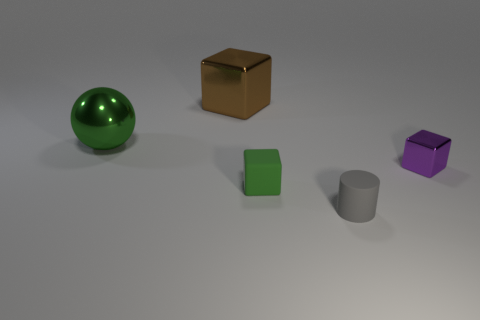What size is the object that is the same color as the rubber block?
Offer a very short reply. Large. How many other objects are the same shape as the big green thing?
Your answer should be very brief. 0. Does the shiny block that is behind the purple cube have the same color as the big sphere?
Provide a short and direct response. No. Are there any small cubes of the same color as the matte cylinder?
Make the answer very short. No. How many green metal things are to the right of the big brown shiny object?
Ensure brevity in your answer.  0. How many other things are there of the same size as the purple metal object?
Provide a succinct answer. 2. Does the thing that is in front of the small green thing have the same material as the tiny thing left of the small gray object?
Provide a short and direct response. Yes. What is the color of the rubber block that is the same size as the purple shiny block?
Make the answer very short. Green. Are there any other things that have the same color as the cylinder?
Offer a terse response. No. How big is the block that is in front of the metal cube that is to the right of the green object in front of the purple thing?
Give a very brief answer. Small. 